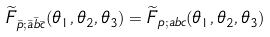Convert formula to latex. <formula><loc_0><loc_0><loc_500><loc_500>\widetilde { F } _ { \bar { p } ; \bar { a } \bar { b } \bar { c } } ( \theta _ { 1 } , \theta _ { 2 } , \theta _ { 3 } ) = \widetilde { F } _ { p ; a b c } ( \theta _ { 1 } , \theta _ { 2 } , \theta _ { 3 } )</formula> 